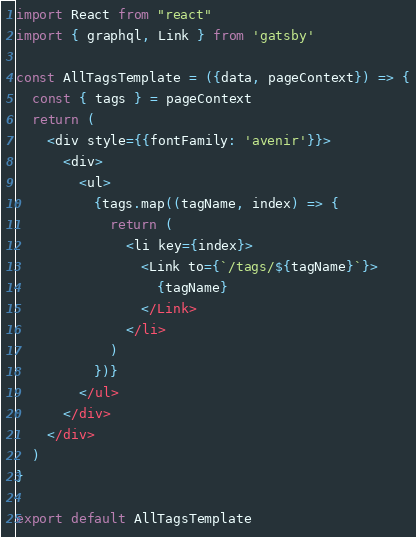Convert code to text. <code><loc_0><loc_0><loc_500><loc_500><_JavaScript_>
import React from "react"
import { graphql, Link } from 'gatsby'

const AllTagsTemplate = ({data, pageContext}) => {
  const { tags } = pageContext
  return (
    <div style={{fontFamily: 'avenir'}}>
      <div>
        <ul>
          {tags.map((tagName, index) => {
            return (
              <li key={index}>
                <Link to={`/tags/${tagName}`}>
                  {tagName}
                </Link>
              </li>
            )
          })}
        </ul>
      </div>
    </div>
  )
}

export default AllTagsTemplate</code> 